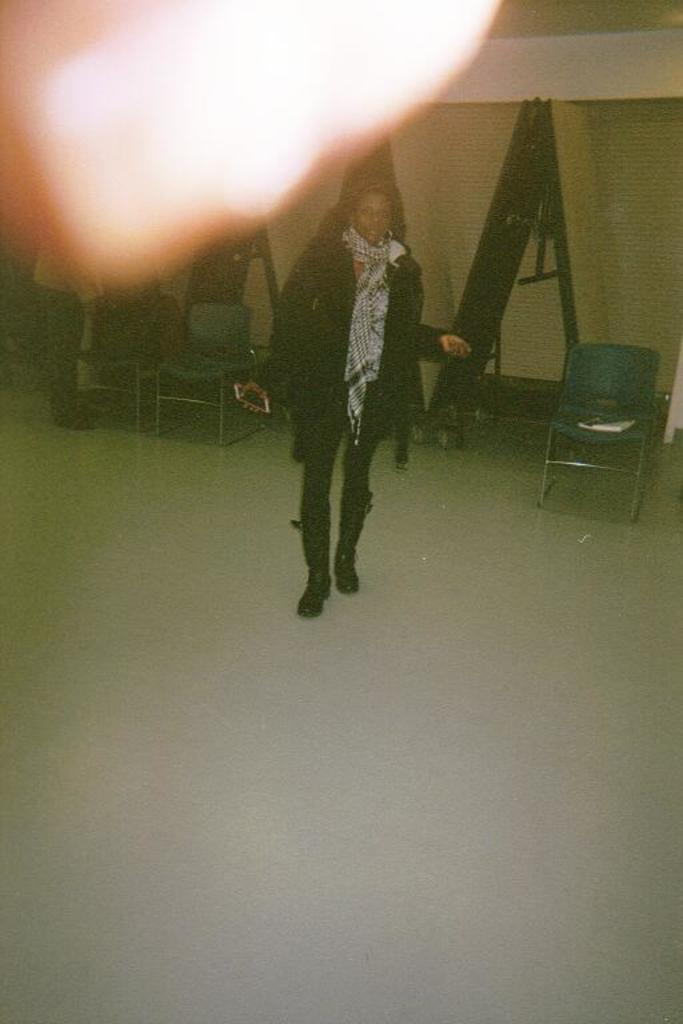What is the main subject in the image? There is a woman standing in the image. What else can be seen in the image besides the woman? Chairs are visible in the image. What type of flowers are growing on the island in the image? There is no island or flowers present in the image; it only features a woman and chairs. 